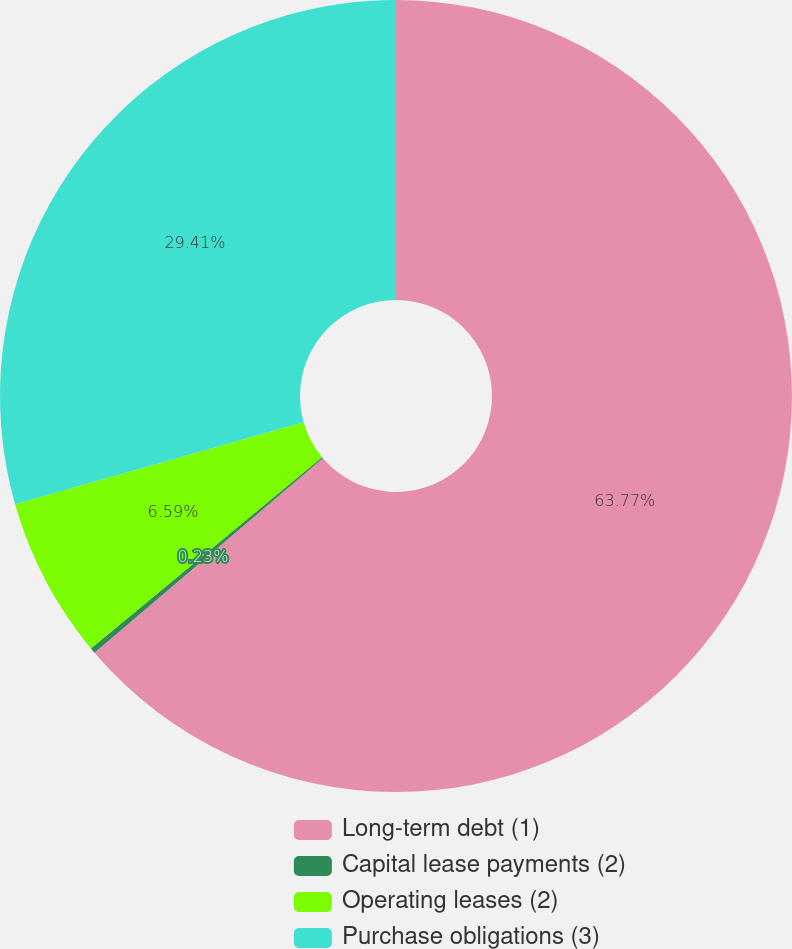Convert chart to OTSL. <chart><loc_0><loc_0><loc_500><loc_500><pie_chart><fcel>Long-term debt (1)<fcel>Capital lease payments (2)<fcel>Operating leases (2)<fcel>Purchase obligations (3)<nl><fcel>63.77%<fcel>0.23%<fcel>6.59%<fcel>29.41%<nl></chart> 